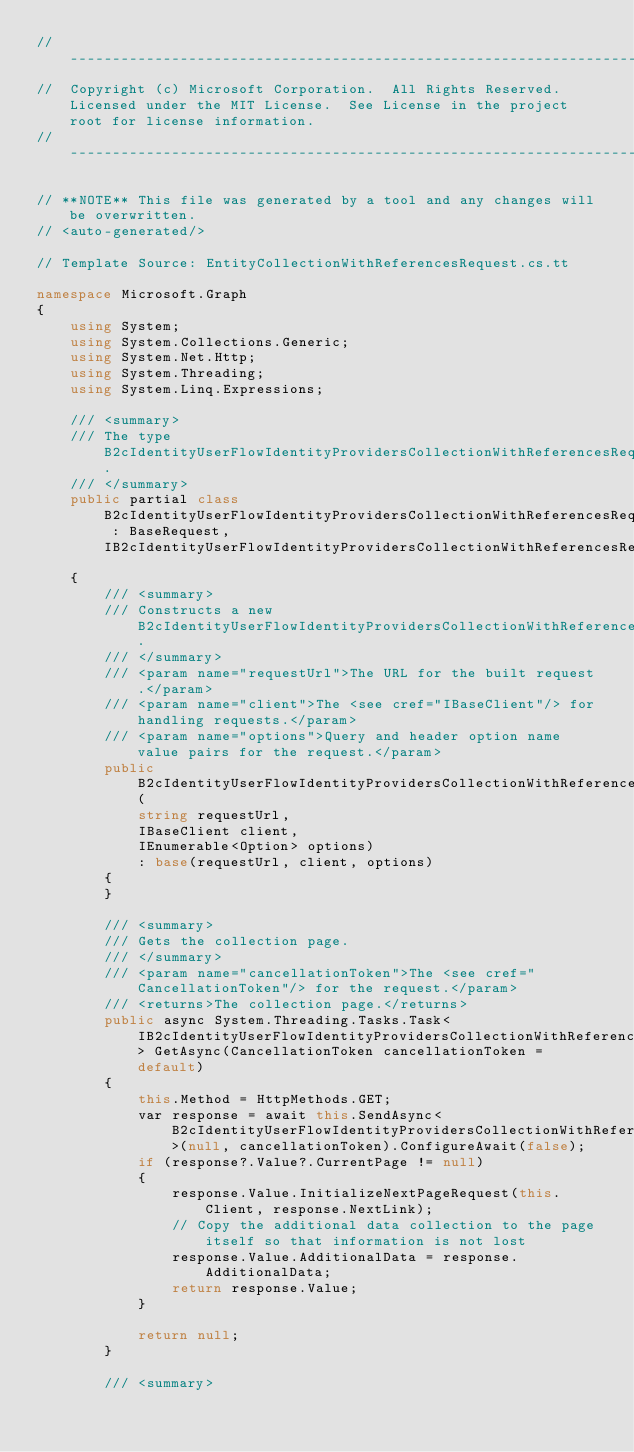Convert code to text. <code><loc_0><loc_0><loc_500><loc_500><_C#_>// ------------------------------------------------------------------------------
//  Copyright (c) Microsoft Corporation.  All Rights Reserved.  Licensed under the MIT License.  See License in the project root for license information.
// ------------------------------------------------------------------------------

// **NOTE** This file was generated by a tool and any changes will be overwritten.
// <auto-generated/>

// Template Source: EntityCollectionWithReferencesRequest.cs.tt

namespace Microsoft.Graph
{
    using System;
    using System.Collections.Generic;
    using System.Net.Http;
    using System.Threading;
    using System.Linq.Expressions;

    /// <summary>
    /// The type B2cIdentityUserFlowIdentityProvidersCollectionWithReferencesRequest.
    /// </summary>
    public partial class B2cIdentityUserFlowIdentityProvidersCollectionWithReferencesRequest : BaseRequest, IB2cIdentityUserFlowIdentityProvidersCollectionWithReferencesRequest
    {
        /// <summary>
        /// Constructs a new B2cIdentityUserFlowIdentityProvidersCollectionWithReferencesRequest.
        /// </summary>
        /// <param name="requestUrl">The URL for the built request.</param>
        /// <param name="client">The <see cref="IBaseClient"/> for handling requests.</param>
        /// <param name="options">Query and header option name value pairs for the request.</param>
        public B2cIdentityUserFlowIdentityProvidersCollectionWithReferencesRequest(
            string requestUrl,
            IBaseClient client,
            IEnumerable<Option> options)
            : base(requestUrl, client, options)
        {
        }

        /// <summary>
        /// Gets the collection page.
        /// </summary>
        /// <param name="cancellationToken">The <see cref="CancellationToken"/> for the request.</param>
        /// <returns>The collection page.</returns>
        public async System.Threading.Tasks.Task<IB2cIdentityUserFlowIdentityProvidersCollectionWithReferencesPage> GetAsync(CancellationToken cancellationToken = default)
        {
            this.Method = HttpMethods.GET;
            var response = await this.SendAsync<B2cIdentityUserFlowIdentityProvidersCollectionWithReferencesResponse>(null, cancellationToken).ConfigureAwait(false);
            if (response?.Value?.CurrentPage != null)
            {
                response.Value.InitializeNextPageRequest(this.Client, response.NextLink);
                // Copy the additional data collection to the page itself so that information is not lost
                response.Value.AdditionalData = response.AdditionalData;
                return response.Value;
            }

            return null;
        }

        /// <summary></code> 